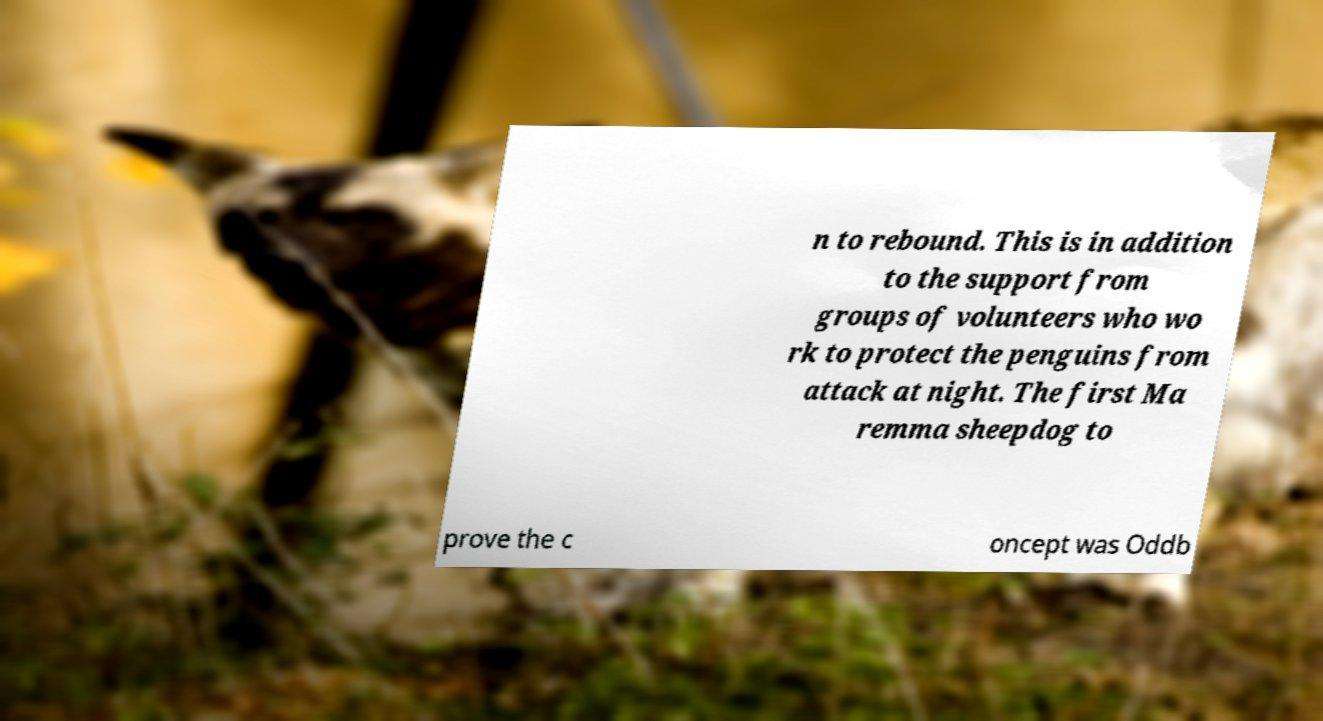What messages or text are displayed in this image? I need them in a readable, typed format. n to rebound. This is in addition to the support from groups of volunteers who wo rk to protect the penguins from attack at night. The first Ma remma sheepdog to prove the c oncept was Oddb 